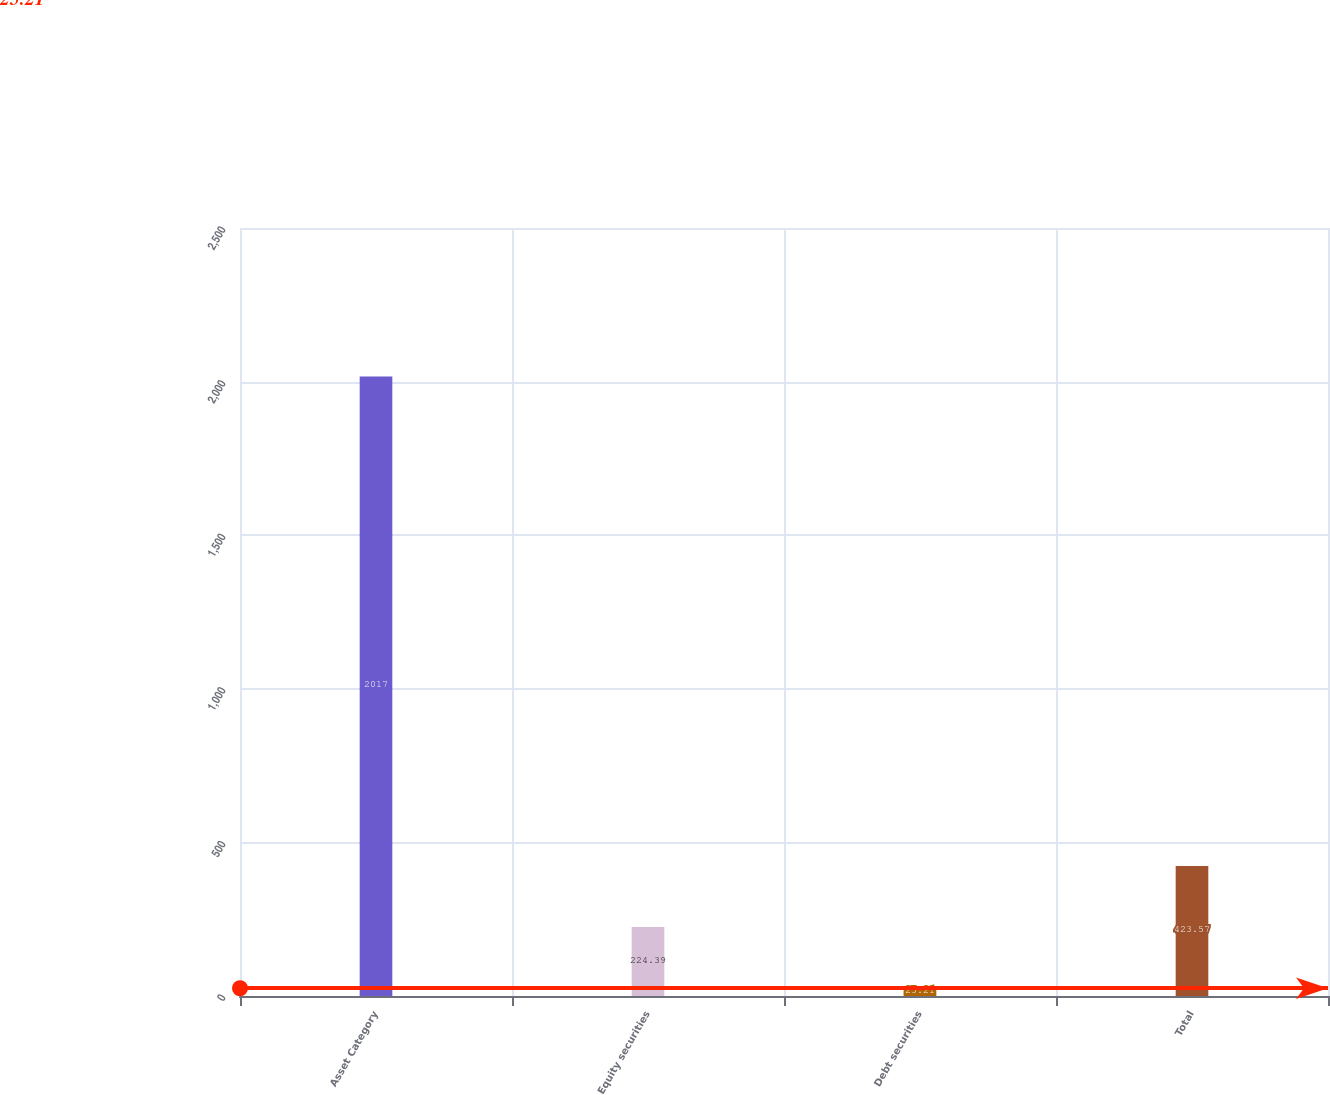Convert chart. <chart><loc_0><loc_0><loc_500><loc_500><bar_chart><fcel>Asset Category<fcel>Equity securities<fcel>Debt securities<fcel>Total<nl><fcel>2017<fcel>224.39<fcel>25.21<fcel>423.57<nl></chart> 